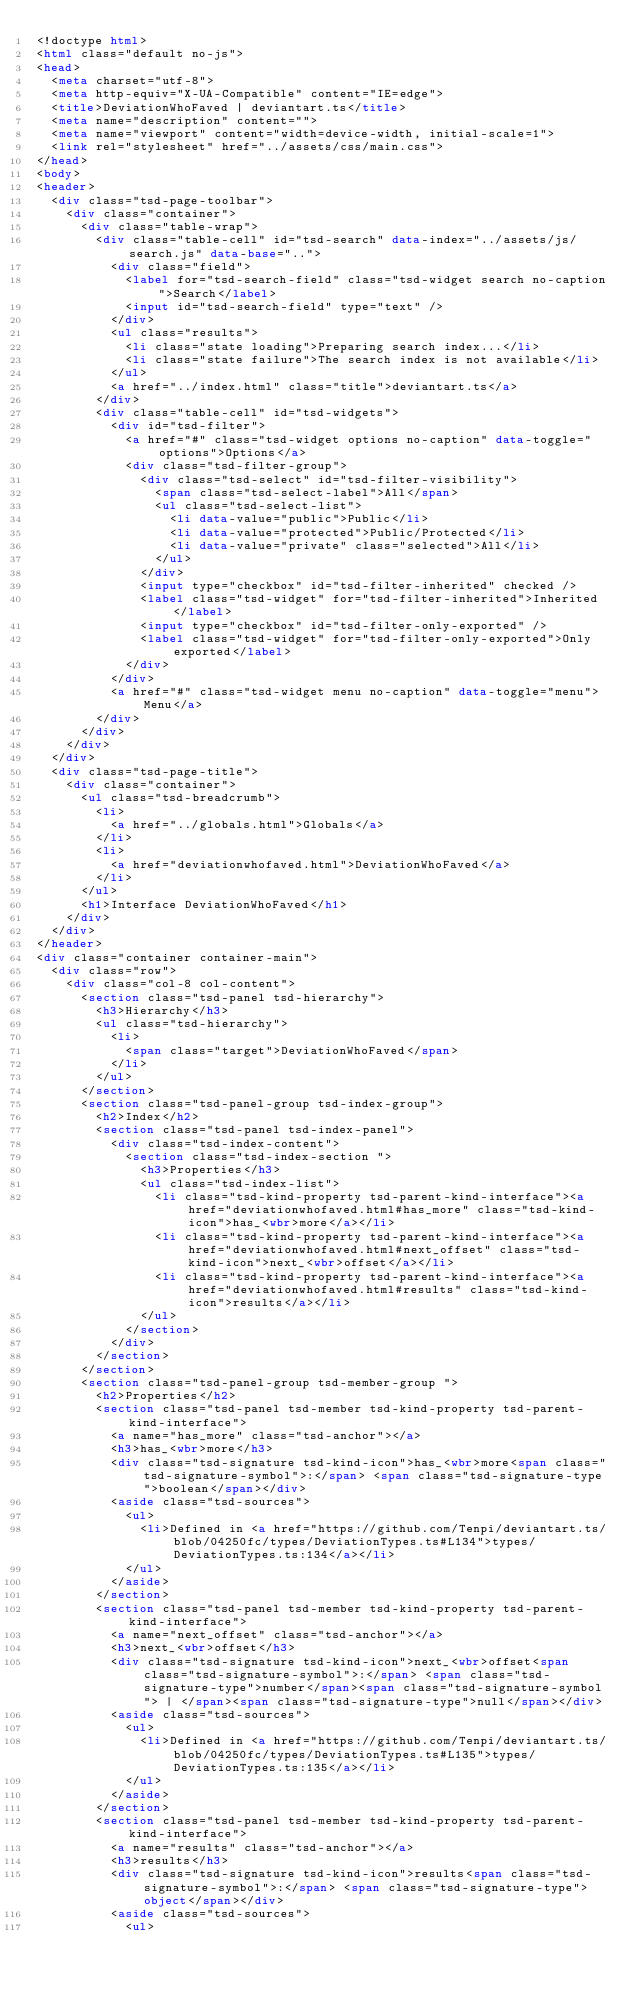<code> <loc_0><loc_0><loc_500><loc_500><_HTML_><!doctype html>
<html class="default no-js">
<head>
	<meta charset="utf-8">
	<meta http-equiv="X-UA-Compatible" content="IE=edge">
	<title>DeviationWhoFaved | deviantart.ts</title>
	<meta name="description" content="">
	<meta name="viewport" content="width=device-width, initial-scale=1">
	<link rel="stylesheet" href="../assets/css/main.css">
</head>
<body>
<header>
	<div class="tsd-page-toolbar">
		<div class="container">
			<div class="table-wrap">
				<div class="table-cell" id="tsd-search" data-index="../assets/js/search.js" data-base="..">
					<div class="field">
						<label for="tsd-search-field" class="tsd-widget search no-caption">Search</label>
						<input id="tsd-search-field" type="text" />
					</div>
					<ul class="results">
						<li class="state loading">Preparing search index...</li>
						<li class="state failure">The search index is not available</li>
					</ul>
					<a href="../index.html" class="title">deviantart.ts</a>
				</div>
				<div class="table-cell" id="tsd-widgets">
					<div id="tsd-filter">
						<a href="#" class="tsd-widget options no-caption" data-toggle="options">Options</a>
						<div class="tsd-filter-group">
							<div class="tsd-select" id="tsd-filter-visibility">
								<span class="tsd-select-label">All</span>
								<ul class="tsd-select-list">
									<li data-value="public">Public</li>
									<li data-value="protected">Public/Protected</li>
									<li data-value="private" class="selected">All</li>
								</ul>
							</div>
							<input type="checkbox" id="tsd-filter-inherited" checked />
							<label class="tsd-widget" for="tsd-filter-inherited">Inherited</label>
							<input type="checkbox" id="tsd-filter-only-exported" />
							<label class="tsd-widget" for="tsd-filter-only-exported">Only exported</label>
						</div>
					</div>
					<a href="#" class="tsd-widget menu no-caption" data-toggle="menu">Menu</a>
				</div>
			</div>
		</div>
	</div>
	<div class="tsd-page-title">
		<div class="container">
			<ul class="tsd-breadcrumb">
				<li>
					<a href="../globals.html">Globals</a>
				</li>
				<li>
					<a href="deviationwhofaved.html">DeviationWhoFaved</a>
				</li>
			</ul>
			<h1>Interface DeviationWhoFaved</h1>
		</div>
	</div>
</header>
<div class="container container-main">
	<div class="row">
		<div class="col-8 col-content">
			<section class="tsd-panel tsd-hierarchy">
				<h3>Hierarchy</h3>
				<ul class="tsd-hierarchy">
					<li>
						<span class="target">DeviationWhoFaved</span>
					</li>
				</ul>
			</section>
			<section class="tsd-panel-group tsd-index-group">
				<h2>Index</h2>
				<section class="tsd-panel tsd-index-panel">
					<div class="tsd-index-content">
						<section class="tsd-index-section ">
							<h3>Properties</h3>
							<ul class="tsd-index-list">
								<li class="tsd-kind-property tsd-parent-kind-interface"><a href="deviationwhofaved.html#has_more" class="tsd-kind-icon">has_<wbr>more</a></li>
								<li class="tsd-kind-property tsd-parent-kind-interface"><a href="deviationwhofaved.html#next_offset" class="tsd-kind-icon">next_<wbr>offset</a></li>
								<li class="tsd-kind-property tsd-parent-kind-interface"><a href="deviationwhofaved.html#results" class="tsd-kind-icon">results</a></li>
							</ul>
						</section>
					</div>
				</section>
			</section>
			<section class="tsd-panel-group tsd-member-group ">
				<h2>Properties</h2>
				<section class="tsd-panel tsd-member tsd-kind-property tsd-parent-kind-interface">
					<a name="has_more" class="tsd-anchor"></a>
					<h3>has_<wbr>more</h3>
					<div class="tsd-signature tsd-kind-icon">has_<wbr>more<span class="tsd-signature-symbol">:</span> <span class="tsd-signature-type">boolean</span></div>
					<aside class="tsd-sources">
						<ul>
							<li>Defined in <a href="https://github.com/Tenpi/deviantart.ts/blob/04250fc/types/DeviationTypes.ts#L134">types/DeviationTypes.ts:134</a></li>
						</ul>
					</aside>
				</section>
				<section class="tsd-panel tsd-member tsd-kind-property tsd-parent-kind-interface">
					<a name="next_offset" class="tsd-anchor"></a>
					<h3>next_<wbr>offset</h3>
					<div class="tsd-signature tsd-kind-icon">next_<wbr>offset<span class="tsd-signature-symbol">:</span> <span class="tsd-signature-type">number</span><span class="tsd-signature-symbol"> | </span><span class="tsd-signature-type">null</span></div>
					<aside class="tsd-sources">
						<ul>
							<li>Defined in <a href="https://github.com/Tenpi/deviantart.ts/blob/04250fc/types/DeviationTypes.ts#L135">types/DeviationTypes.ts:135</a></li>
						</ul>
					</aside>
				</section>
				<section class="tsd-panel tsd-member tsd-kind-property tsd-parent-kind-interface">
					<a name="results" class="tsd-anchor"></a>
					<h3>results</h3>
					<div class="tsd-signature tsd-kind-icon">results<span class="tsd-signature-symbol">:</span> <span class="tsd-signature-type">object</span></div>
					<aside class="tsd-sources">
						<ul></code> 